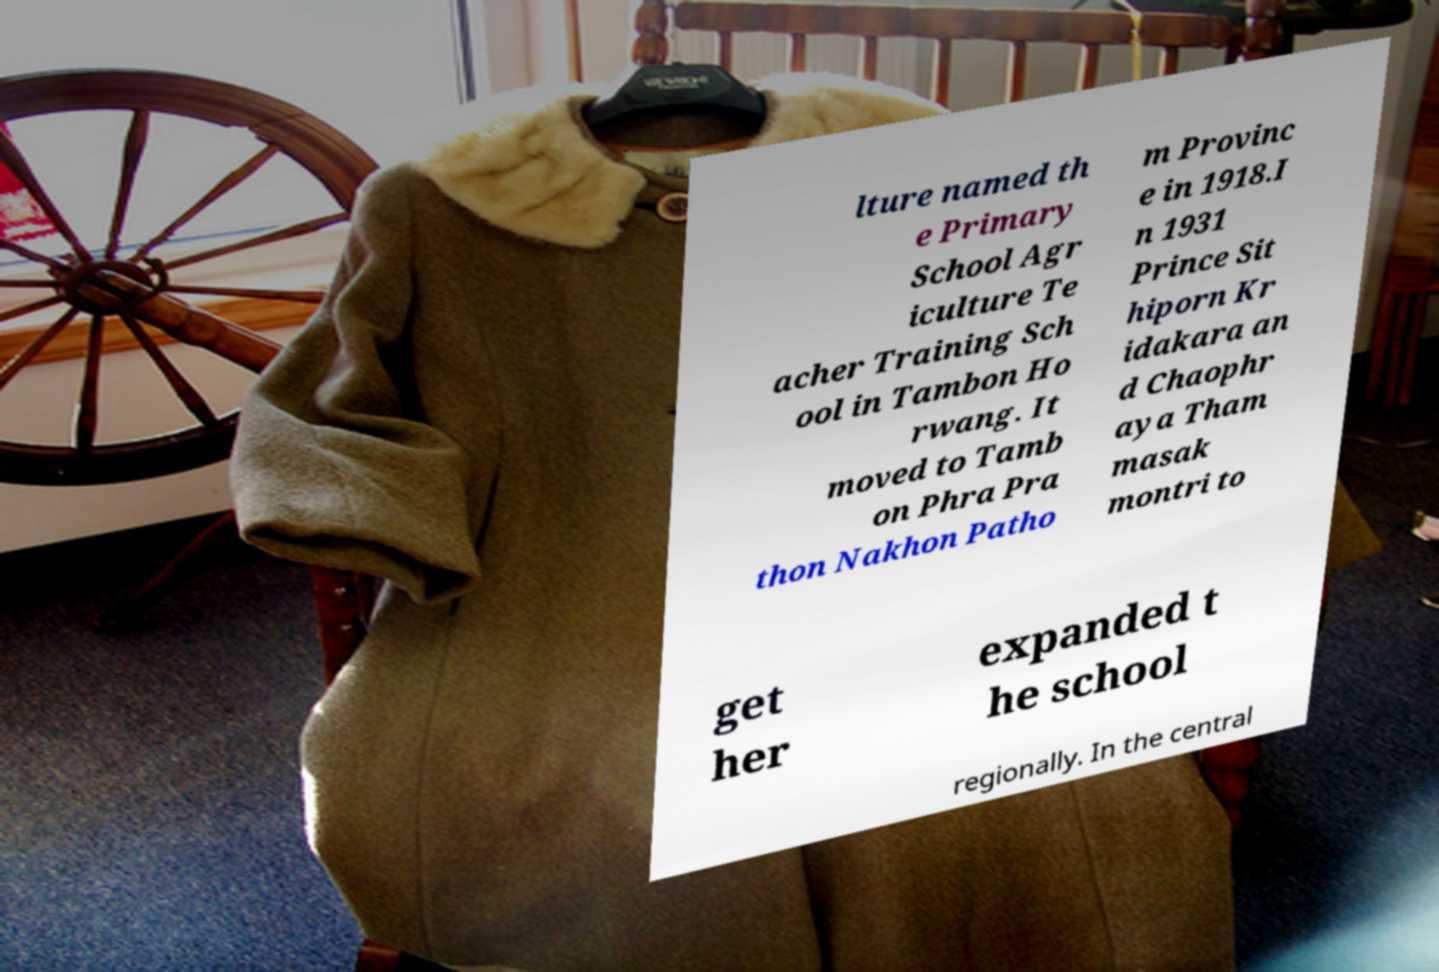Could you assist in decoding the text presented in this image and type it out clearly? lture named th e Primary School Agr iculture Te acher Training Sch ool in Tambon Ho rwang. It moved to Tamb on Phra Pra thon Nakhon Patho m Provinc e in 1918.I n 1931 Prince Sit hiporn Kr idakara an d Chaophr aya Tham masak montri to get her expanded t he school regionally. In the central 